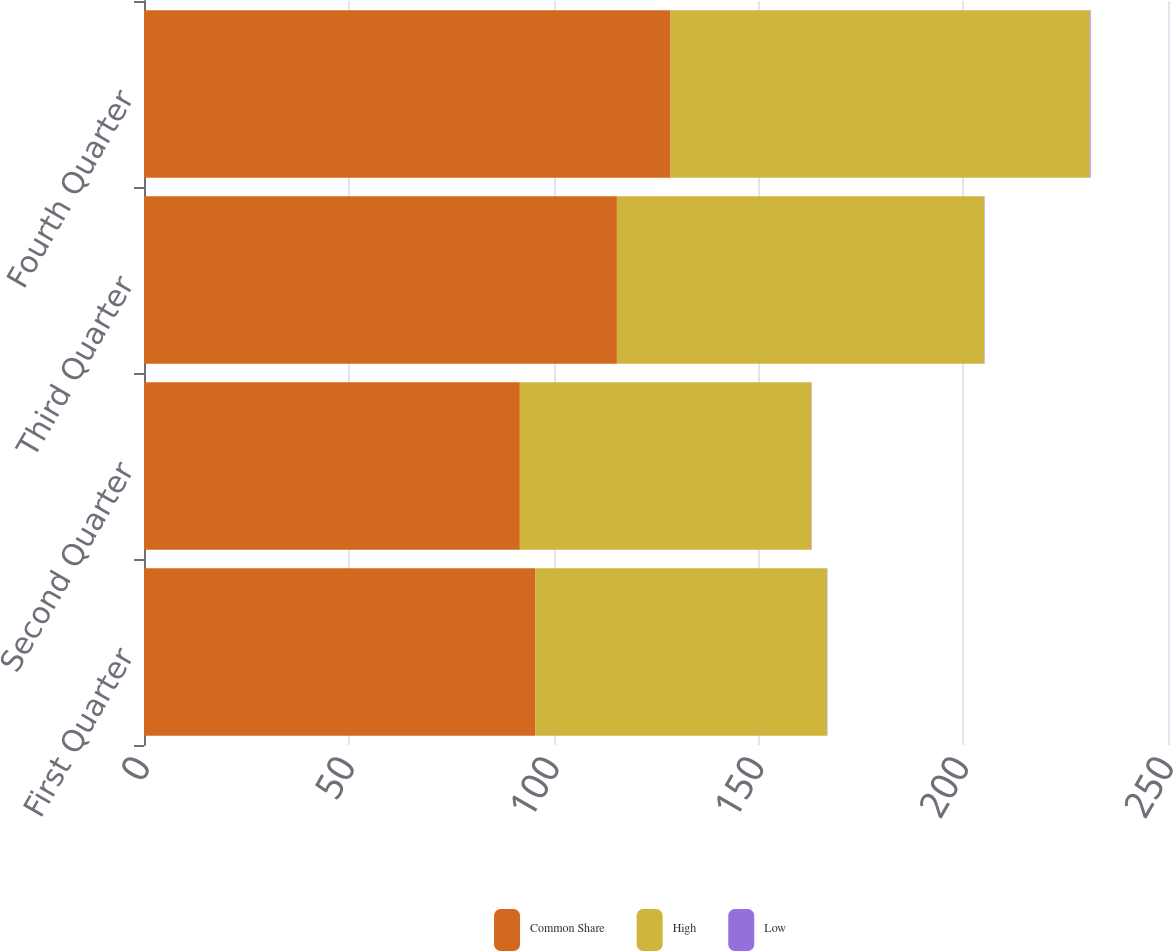Convert chart. <chart><loc_0><loc_0><loc_500><loc_500><stacked_bar_chart><ecel><fcel>First Quarter<fcel>Second Quarter<fcel>Third Quarter<fcel>Fourth Quarter<nl><fcel>Common Share<fcel>95.59<fcel>91.76<fcel>115.45<fcel>128.56<nl><fcel>High<fcel>71.14<fcel>71.12<fcel>89.66<fcel>102.33<nl><fcel>Low<fcel>0.1<fcel>0.1<fcel>0.1<fcel>0.2<nl></chart> 